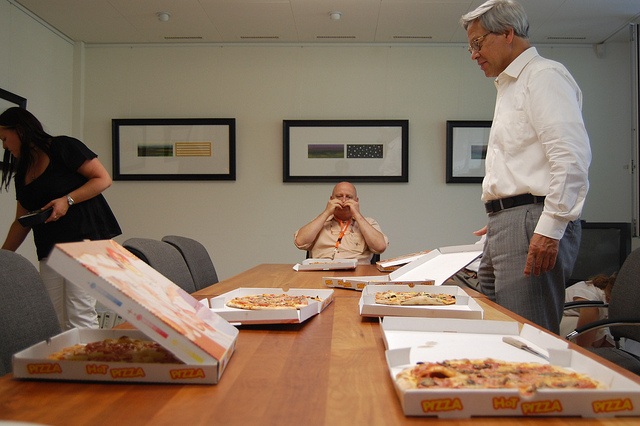Please identify all text content in this image. PIZZA PIZZA PIZZA PIZZA HOT 